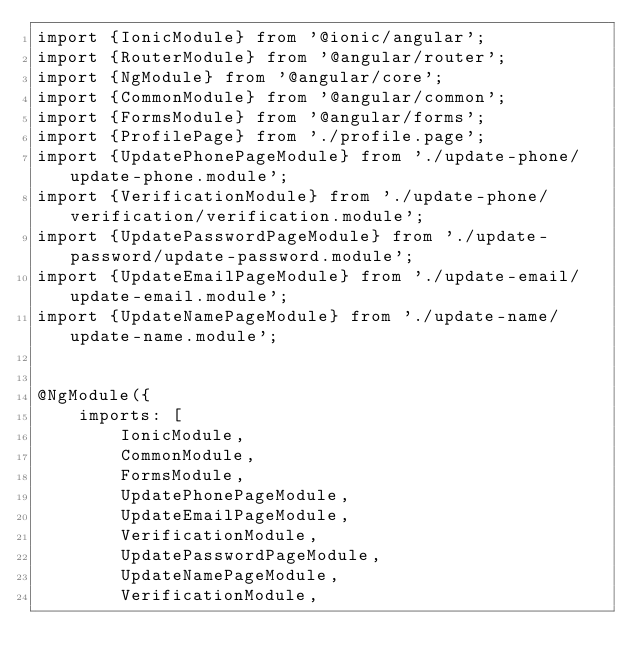Convert code to text. <code><loc_0><loc_0><loc_500><loc_500><_TypeScript_>import {IonicModule} from '@ionic/angular';
import {RouterModule} from '@angular/router';
import {NgModule} from '@angular/core';
import {CommonModule} from '@angular/common';
import {FormsModule} from '@angular/forms';
import {ProfilePage} from './profile.page';
import {UpdatePhonePageModule} from './update-phone/update-phone.module';
import {VerificationModule} from './update-phone/verification/verification.module';
import {UpdatePasswordPageModule} from './update-password/update-password.module';
import {UpdateEmailPageModule} from './update-email/update-email.module';
import {UpdateNamePageModule} from './update-name/update-name.module';


@NgModule({
    imports: [
        IonicModule,
        CommonModule,
        FormsModule,
        UpdatePhonePageModule,
        UpdateEmailPageModule,
        VerificationModule,
        UpdatePasswordPageModule,
        UpdateNamePageModule,
        VerificationModule,</code> 